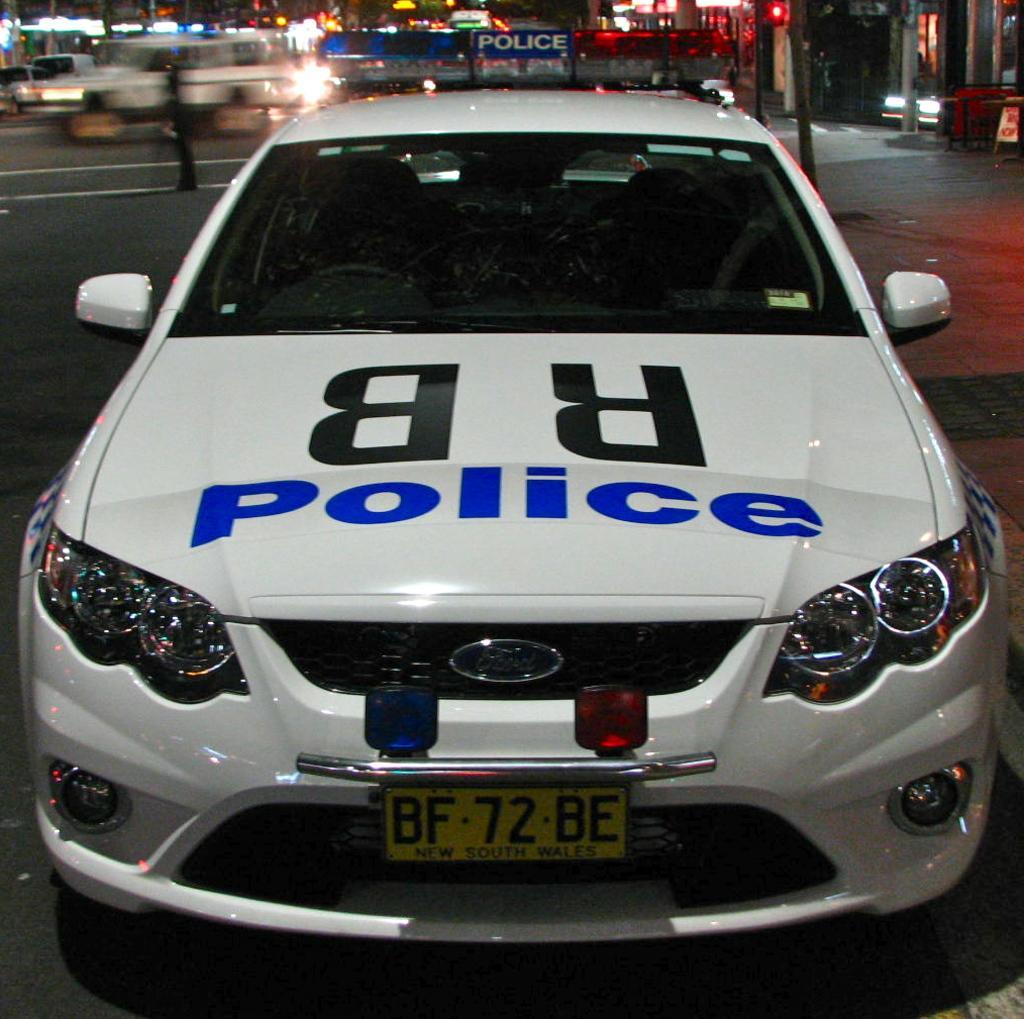Could you give a brief overview of what you see in this image? In this image I can see few vehicles on the road. In front the vehicle is in white color, background i can see few buildings and I can also see few lights. 